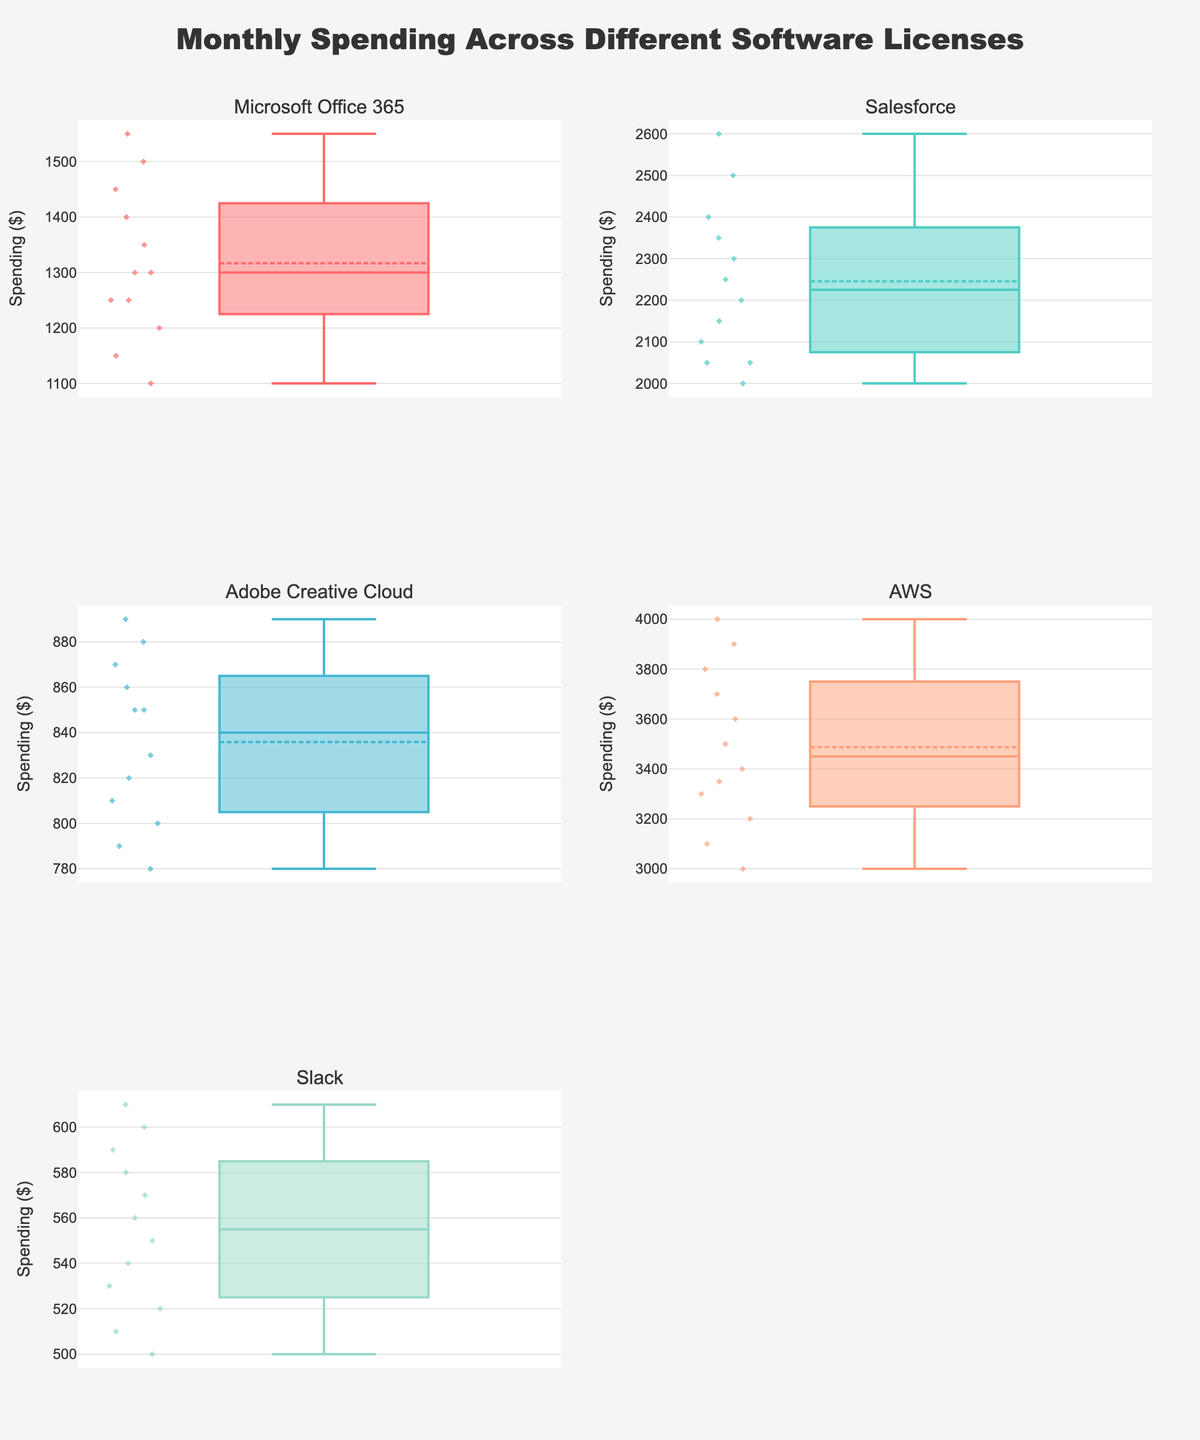What is the title of the figure? The title is clearly displayed at the top of the figure. It focuses on the overall theme of the visualization: Monthly Spending Across Different Software Licenses.
Answer: Monthly Spending Across Different Software Licenses Which software license has the highest median monthly spending? To find this, look at the line inside each box representing the median value. The median value is highest for AWS.
Answer: AWS How does the spending of Microsoft Office 365 compare to Salesforce in March? Locate the data points (represented by symbols) in March for both Microsoft Office 365 and Salesforce. Microsoft Office 365 has a spending of 1300, while Salesforce has 2050 in March. Compare 1300 to 2050 to see that Salesforce has higher spending.
Answer: Salesforce is higher What is the interquartile range (IQR) for Adobe Creative Cloud? Identify the edges of the box for Adobe Creative Cloud, representing the 25th and 75th percentiles. Subtract the 25th percentile from the 75th percentile to find the IQR. The 25th percentile is around 800, and the 75th percentile is about 870.
Answer: 70 Which software has the smallest variability in monthly spending? The smaller variability is indicated by the box plots with the smallest distances between the top and bottom whiskers. Slack shows the smallest box and whiskers range, indicating the least variability.
Answer: Slack How do the average spending values of AWS and Microsoft Office 365 compare? The average is represented by a line mark within the boxes. Compare the average spending values of AWS and Microsoft Office 365 visually; AWS has a significantly higher average spending.
Answer: AWS is higher Is the spending distribution of Salesforce skewed? Examine the shape of the box plot for Salesforce. If one whisker is longer than the other, or if the median line is closer to one end of the box, this indicates skewness. Salesforce shows a slight right skew, denoted by a longer upper whisker.
Answer: Slightly right-skewed What is the range of Slack's monthly spending? Identify the minimum and maximum data points within the whiskers on Slack's box plot. The minimum is around 500, while the maximum is around 610.
Answer: 110 Which month's spending for AWS exceeds 3700? Look for data points for AWS above the value of 3700. The months of October, November, and December have spending that exceeds 3700.
Answer: October, November, December What is the overall trend in monthly spending for Microsoft Office 365 throughout the year? Observe the data points for each month and note the general direction of spending levels. Microsoft Office 365 shows fluctuations but generally increases towards the end of the year.
Answer: Increasing towards the end 